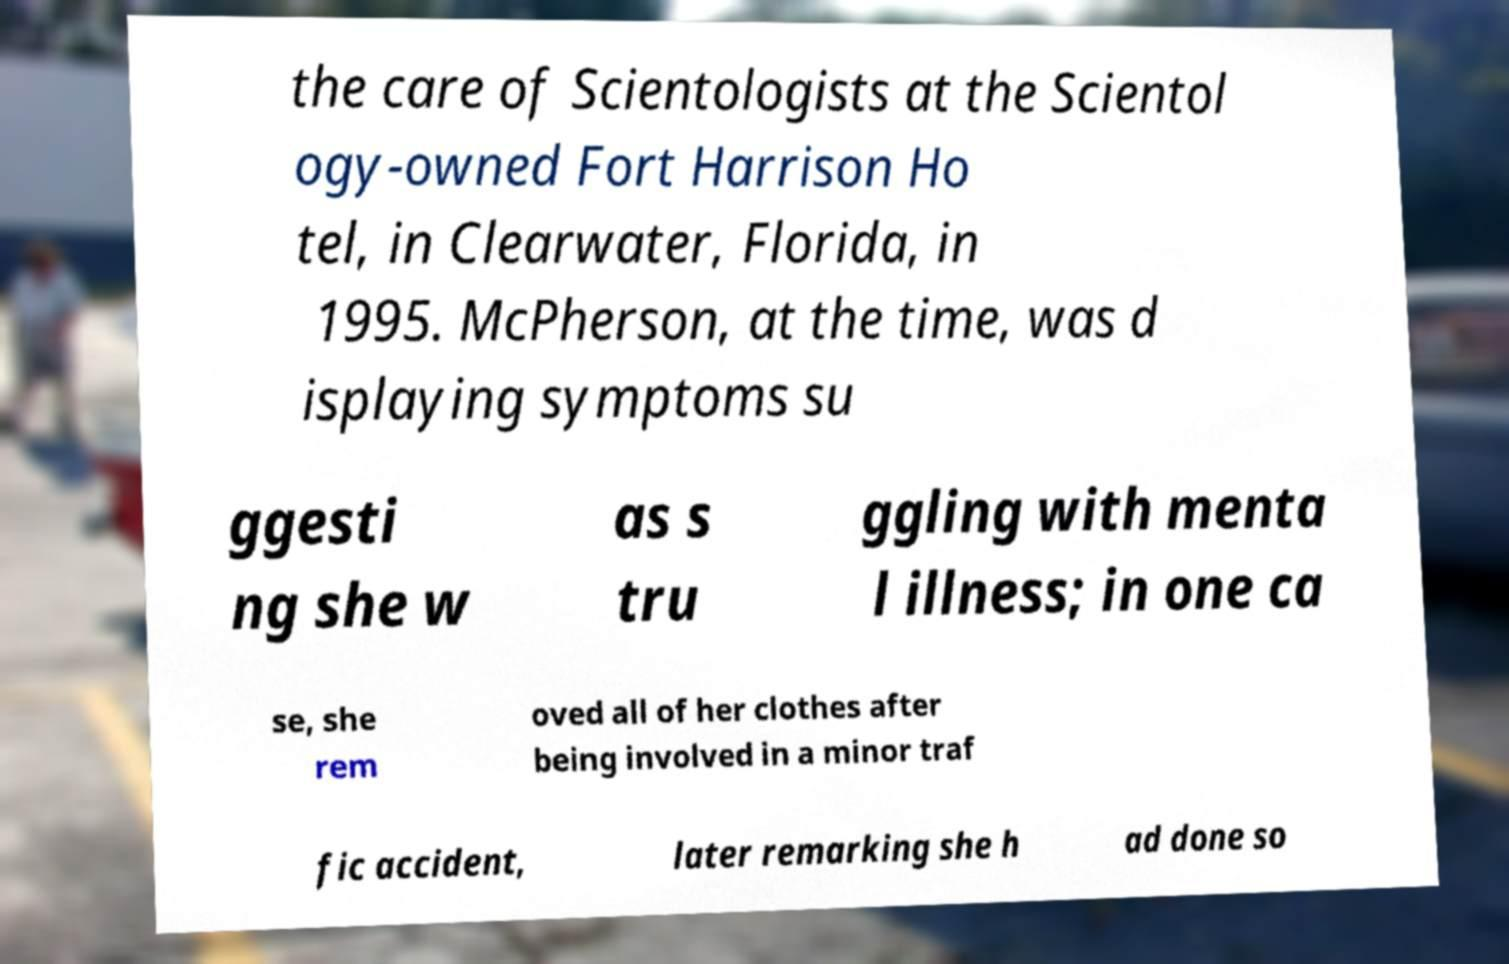Please identify and transcribe the text found in this image. the care of Scientologists at the Scientol ogy-owned Fort Harrison Ho tel, in Clearwater, Florida, in 1995. McPherson, at the time, was d isplaying symptoms su ggesti ng she w as s tru ggling with menta l illness; in one ca se, she rem oved all of her clothes after being involved in a minor traf fic accident, later remarking she h ad done so 